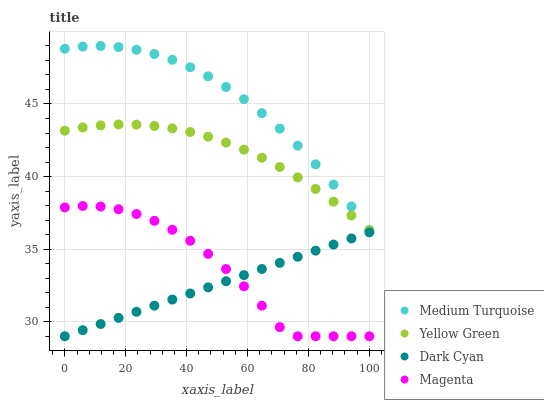Does Dark Cyan have the minimum area under the curve?
Answer yes or no. Yes. Does Medium Turquoise have the maximum area under the curve?
Answer yes or no. Yes. Does Magenta have the minimum area under the curve?
Answer yes or no. No. Does Magenta have the maximum area under the curve?
Answer yes or no. No. Is Dark Cyan the smoothest?
Answer yes or no. Yes. Is Magenta the roughest?
Answer yes or no. Yes. Is Yellow Green the smoothest?
Answer yes or no. No. Is Yellow Green the roughest?
Answer yes or no. No. Does Dark Cyan have the lowest value?
Answer yes or no. Yes. Does Yellow Green have the lowest value?
Answer yes or no. No. Does Medium Turquoise have the highest value?
Answer yes or no. Yes. Does Magenta have the highest value?
Answer yes or no. No. Is Magenta less than Medium Turquoise?
Answer yes or no. Yes. Is Medium Turquoise greater than Magenta?
Answer yes or no. Yes. Does Magenta intersect Dark Cyan?
Answer yes or no. Yes. Is Magenta less than Dark Cyan?
Answer yes or no. No. Is Magenta greater than Dark Cyan?
Answer yes or no. No. Does Magenta intersect Medium Turquoise?
Answer yes or no. No. 